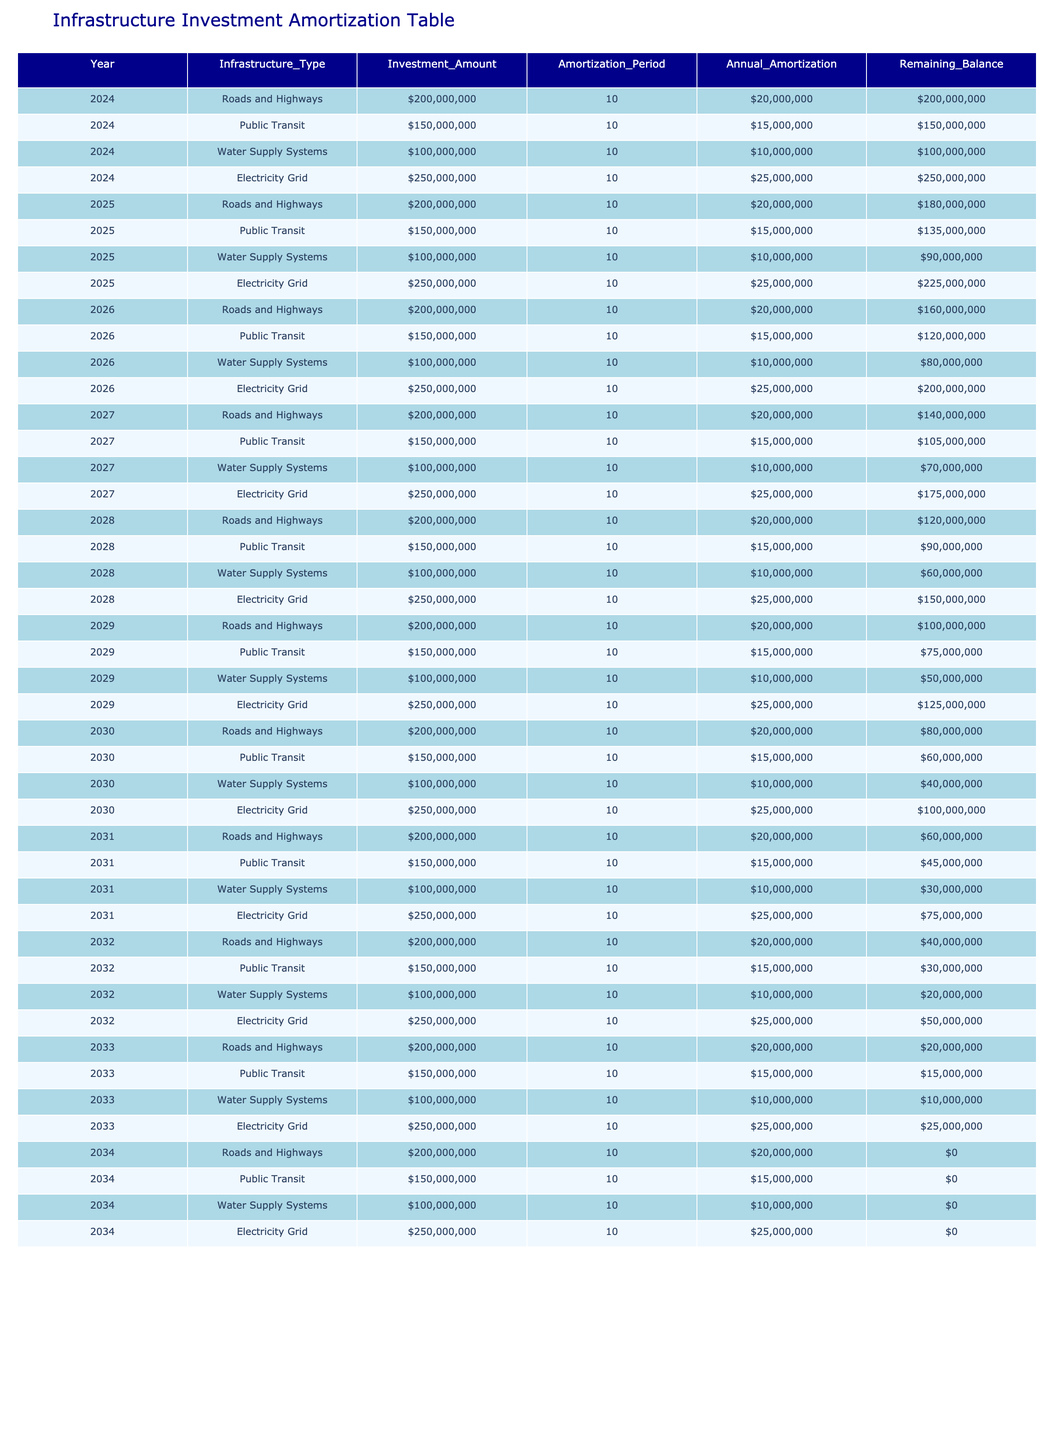What is the total investment amount for the Electricity Grid? To find the total investment amount for the Electricity Grid, we look at the rows corresponding to this type in the table. Each year from 2024 to 2034 has an investment amount of 250,000,000. There are 11 years of investments (2024 to 2034), so we multiply 250,000,000 by 11: 250,000,000 * 11 = 2,750,000,000.
Answer: 2,750,000,000 What is the annual amortization for Public Transit each year? Each entry for the Public Transit in the table consistently shows an annual amortization of 15,000,000 for every year from 2024 to 2034.
Answer: 15,000,000 Is the remaining balance for Water Supply Systems zero at any point in the table? We check the entries for Water Supply Systems and see that the remaining balance reduces consistently and reaches zero at the end of 2034. Therefore, the statement is true.
Answer: Yes What is the remaining balance for Roads and Highways in 2031? Referring to the row for Roads and Highways for the year 2031, the remaining balance is explicitly stated as 60,000,000.
Answer: 60,000,000 What is the total amount of investment over the decade for all infrastructure types? To find the total investment, we sum the investment amounts for each infrastructure type for each year from 2024 to 2034. Each type of infrastructure has a total of 2,000,000,000 (from 200,000,000 a year for 10 years) giving us: Roads (2,000,000,000) + Public Transit (1,500,000,000) + Water Supply Systems (1,000,000,000) + Electricity Grid (2,500,000,000) = 7,000,000,000.
Answer: 7,000,000,000 What is the average remaining balance for the Electricity Grid from 2024 to 2034? We find the remaining balances for the Electricity Grid for each year and then average them. The balances are: 250,000,000 (2024), 225,000,000 (2025), 200,000,000 (2026), 175,000,000 (2027), 150,000,000 (2028), 125,000,000 (2029), 100,000,000 (2030), 75,000,000 (2031), 50,000,000 (2032), 25,000,000 (2033), and 0 (2034). The total is 1,450,000,000 for 11 years, and the average is 1,450,000,000 / 11 = 131,818,182.
Answer: 131,818,182 